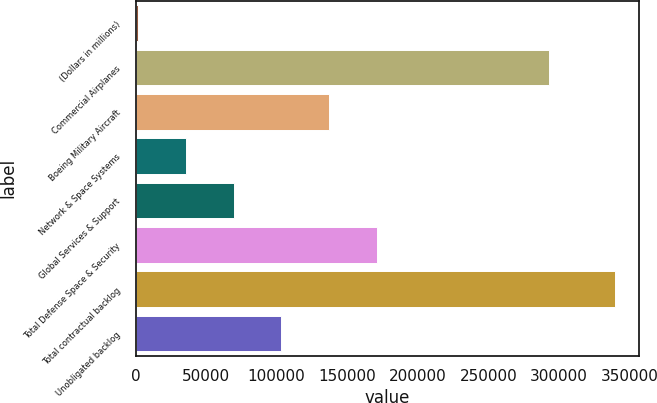Convert chart to OTSL. <chart><loc_0><loc_0><loc_500><loc_500><bar_chart><fcel>(Dollars in millions)<fcel>Commercial Airplanes<fcel>Boeing Military Aircraft<fcel>Network & Space Systems<fcel>Global Services & Support<fcel>Total Defense Space & Security<fcel>Total contractual backlog<fcel>Unobligated backlog<nl><fcel>2011<fcel>293303<fcel>137069<fcel>35775.6<fcel>69540.2<fcel>170834<fcel>339657<fcel>103305<nl></chart> 